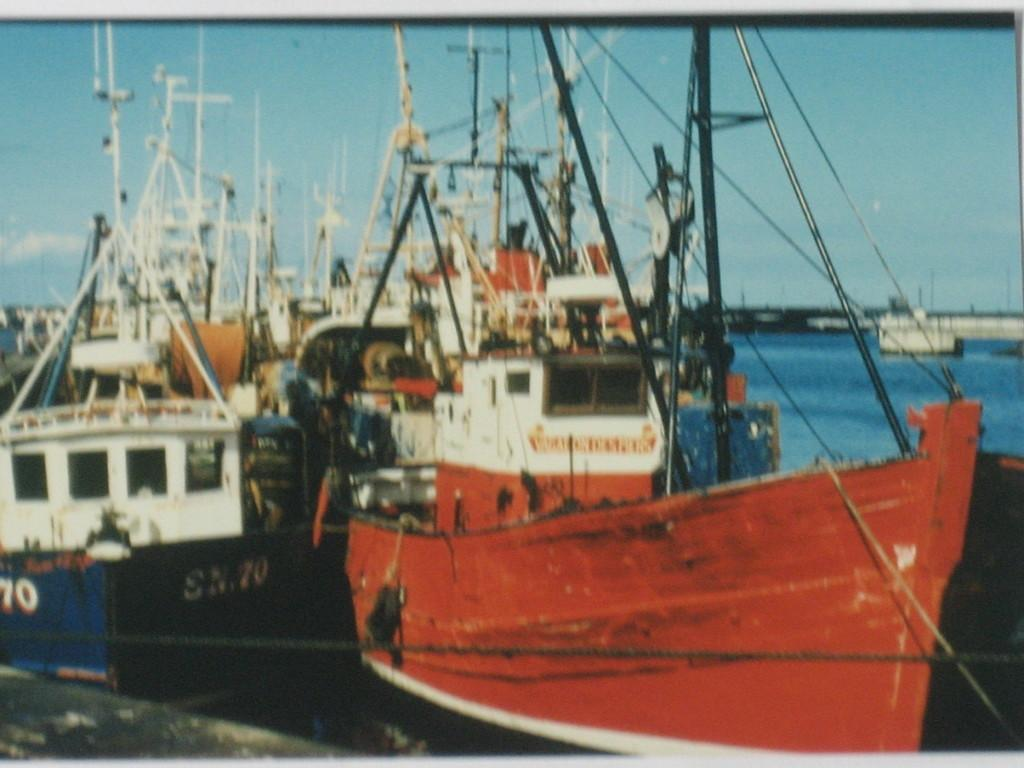<image>
Offer a succinct explanation of the picture presented. S.N.70 is written in white on the side of a black boat. 